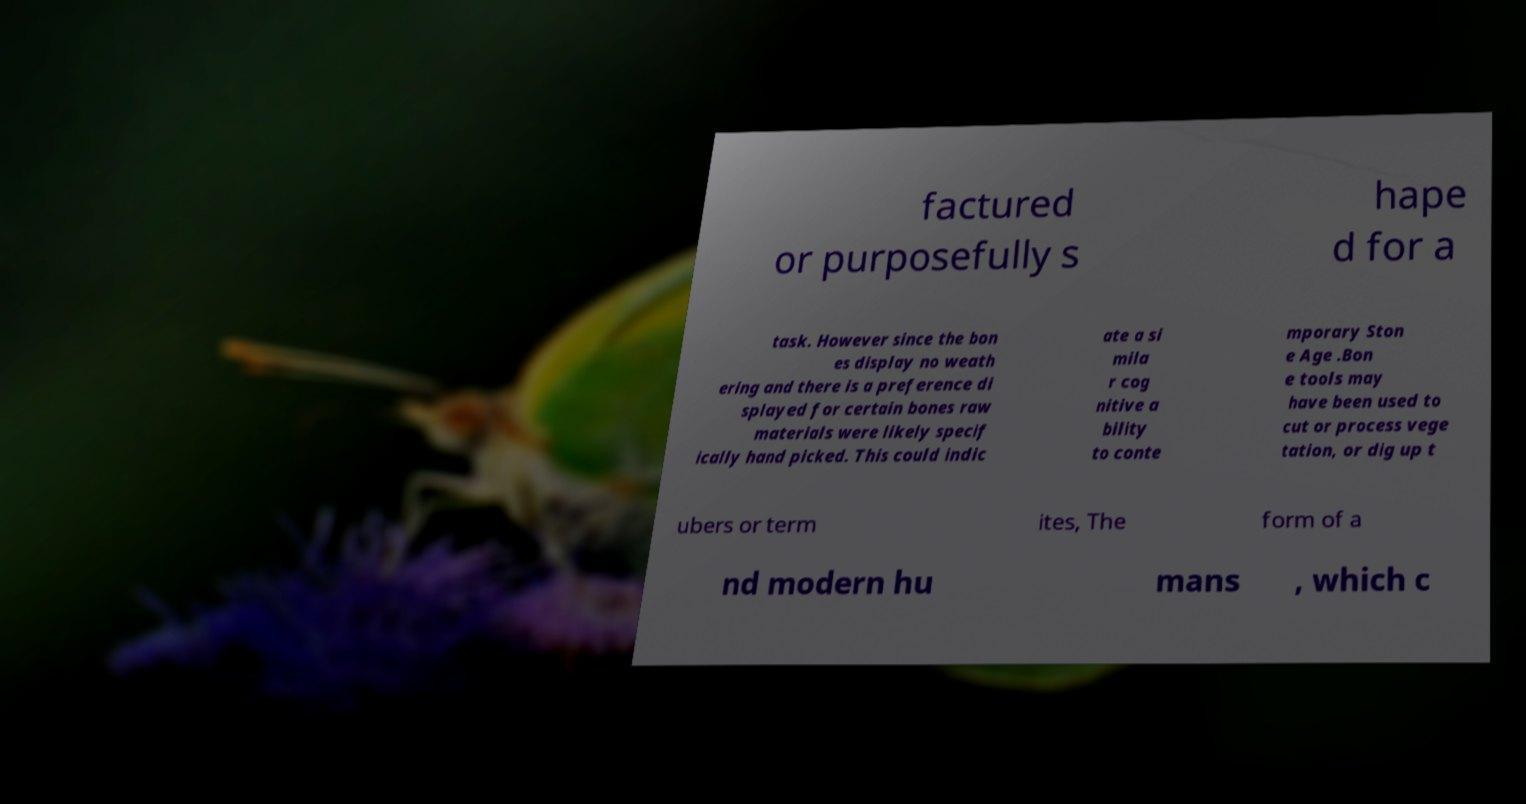What messages or text are displayed in this image? I need them in a readable, typed format. factured or purposefully s hape d for a task. However since the bon es display no weath ering and there is a preference di splayed for certain bones raw materials were likely specif ically hand picked. This could indic ate a si mila r cog nitive a bility to conte mporary Ston e Age .Bon e tools may have been used to cut or process vege tation, or dig up t ubers or term ites, The form of a nd modern hu mans , which c 